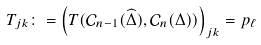<formula> <loc_0><loc_0><loc_500><loc_500>T _ { j k } \colon = \left ( T ( \mathcal { C } _ { n - 1 } ( \widehat { \Delta } ) , \mathcal { C } _ { n } ( \Delta ) ) \right ) _ { j k } = p _ { \ell } \text { }</formula> 